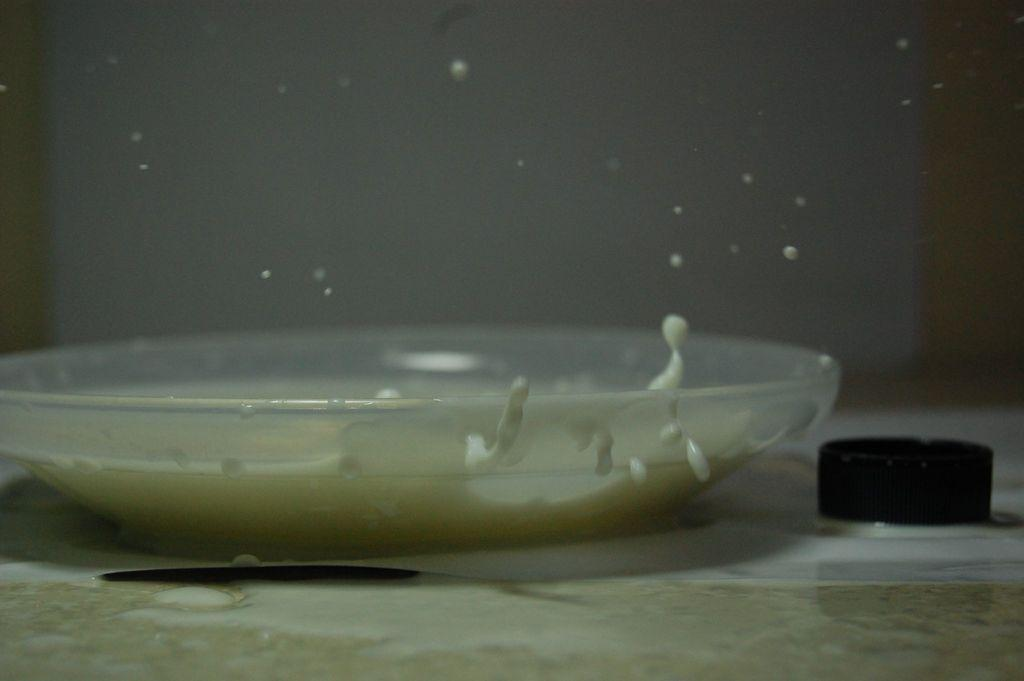What is the main object in the image? There is a container in the image. What is inside the container? The container holds milk. Is there anything on top of the milk? Yes, there is a lid on the surface of the milk. What color is the crayon floating in the milk? There is no crayon present in the image; it only shows a container with milk and a lid. 